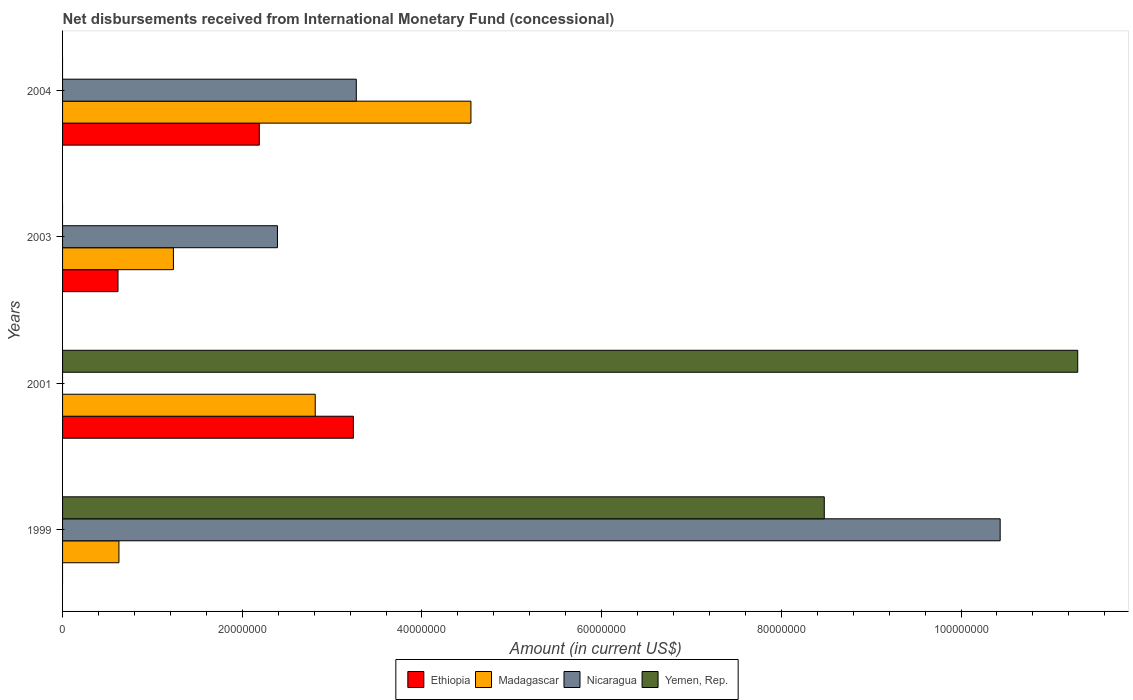How many bars are there on the 1st tick from the top?
Ensure brevity in your answer.  3. How many bars are there on the 3rd tick from the bottom?
Make the answer very short. 3. What is the amount of disbursements received from International Monetary Fund in Madagascar in 1999?
Keep it short and to the point. 6.27e+06. Across all years, what is the maximum amount of disbursements received from International Monetary Fund in Yemen, Rep.?
Keep it short and to the point. 1.13e+08. In which year was the amount of disbursements received from International Monetary Fund in Ethiopia maximum?
Provide a short and direct response. 2001. What is the total amount of disbursements received from International Monetary Fund in Yemen, Rep. in the graph?
Provide a short and direct response. 1.98e+08. What is the difference between the amount of disbursements received from International Monetary Fund in Ethiopia in 2001 and that in 2003?
Your response must be concise. 2.62e+07. What is the difference between the amount of disbursements received from International Monetary Fund in Nicaragua in 2001 and the amount of disbursements received from International Monetary Fund in Madagascar in 1999?
Provide a short and direct response. -6.27e+06. What is the average amount of disbursements received from International Monetary Fund in Yemen, Rep. per year?
Provide a short and direct response. 4.94e+07. In the year 2004, what is the difference between the amount of disbursements received from International Monetary Fund in Madagascar and amount of disbursements received from International Monetary Fund in Nicaragua?
Your answer should be compact. 1.28e+07. What is the ratio of the amount of disbursements received from International Monetary Fund in Madagascar in 1999 to that in 2003?
Your answer should be compact. 0.51. Is the amount of disbursements received from International Monetary Fund in Madagascar in 1999 less than that in 2004?
Your answer should be compact. Yes. What is the difference between the highest and the second highest amount of disbursements received from International Monetary Fund in Nicaragua?
Offer a very short reply. 7.17e+07. What is the difference between the highest and the lowest amount of disbursements received from International Monetary Fund in Madagascar?
Your answer should be very brief. 3.92e+07. Is the sum of the amount of disbursements received from International Monetary Fund in Madagascar in 2001 and 2003 greater than the maximum amount of disbursements received from International Monetary Fund in Yemen, Rep. across all years?
Your answer should be compact. No. Is it the case that in every year, the sum of the amount of disbursements received from International Monetary Fund in Nicaragua and amount of disbursements received from International Monetary Fund in Ethiopia is greater than the sum of amount of disbursements received from International Monetary Fund in Madagascar and amount of disbursements received from International Monetary Fund in Yemen, Rep.?
Offer a very short reply. No. Is it the case that in every year, the sum of the amount of disbursements received from International Monetary Fund in Madagascar and amount of disbursements received from International Monetary Fund in Ethiopia is greater than the amount of disbursements received from International Monetary Fund in Yemen, Rep.?
Your answer should be very brief. No. Are all the bars in the graph horizontal?
Provide a succinct answer. Yes. Are the values on the major ticks of X-axis written in scientific E-notation?
Ensure brevity in your answer.  No. Where does the legend appear in the graph?
Your response must be concise. Bottom center. What is the title of the graph?
Offer a terse response. Net disbursements received from International Monetary Fund (concessional). What is the Amount (in current US$) in Ethiopia in 1999?
Your response must be concise. 0. What is the Amount (in current US$) of Madagascar in 1999?
Your answer should be very brief. 6.27e+06. What is the Amount (in current US$) in Nicaragua in 1999?
Give a very brief answer. 1.04e+08. What is the Amount (in current US$) in Yemen, Rep. in 1999?
Your answer should be compact. 8.48e+07. What is the Amount (in current US$) of Ethiopia in 2001?
Keep it short and to the point. 3.24e+07. What is the Amount (in current US$) in Madagascar in 2001?
Make the answer very short. 2.81e+07. What is the Amount (in current US$) in Yemen, Rep. in 2001?
Your response must be concise. 1.13e+08. What is the Amount (in current US$) of Ethiopia in 2003?
Your answer should be very brief. 6.17e+06. What is the Amount (in current US$) of Madagascar in 2003?
Offer a terse response. 1.23e+07. What is the Amount (in current US$) in Nicaragua in 2003?
Provide a succinct answer. 2.39e+07. What is the Amount (in current US$) of Ethiopia in 2004?
Make the answer very short. 2.19e+07. What is the Amount (in current US$) in Madagascar in 2004?
Your answer should be very brief. 4.55e+07. What is the Amount (in current US$) in Nicaragua in 2004?
Your response must be concise. 3.27e+07. What is the Amount (in current US$) in Yemen, Rep. in 2004?
Offer a very short reply. 0. Across all years, what is the maximum Amount (in current US$) in Ethiopia?
Your answer should be very brief. 3.24e+07. Across all years, what is the maximum Amount (in current US$) in Madagascar?
Make the answer very short. 4.55e+07. Across all years, what is the maximum Amount (in current US$) of Nicaragua?
Your response must be concise. 1.04e+08. Across all years, what is the maximum Amount (in current US$) in Yemen, Rep.?
Offer a very short reply. 1.13e+08. Across all years, what is the minimum Amount (in current US$) in Ethiopia?
Provide a short and direct response. 0. Across all years, what is the minimum Amount (in current US$) in Madagascar?
Offer a very short reply. 6.27e+06. Across all years, what is the minimum Amount (in current US$) of Nicaragua?
Your answer should be compact. 0. Across all years, what is the minimum Amount (in current US$) of Yemen, Rep.?
Provide a succinct answer. 0. What is the total Amount (in current US$) of Ethiopia in the graph?
Offer a very short reply. 6.04e+07. What is the total Amount (in current US$) of Madagascar in the graph?
Your answer should be very brief. 9.22e+07. What is the total Amount (in current US$) in Nicaragua in the graph?
Give a very brief answer. 1.61e+08. What is the total Amount (in current US$) in Yemen, Rep. in the graph?
Offer a very short reply. 1.98e+08. What is the difference between the Amount (in current US$) in Madagascar in 1999 and that in 2001?
Your answer should be very brief. -2.18e+07. What is the difference between the Amount (in current US$) in Yemen, Rep. in 1999 and that in 2001?
Your answer should be compact. -2.82e+07. What is the difference between the Amount (in current US$) of Madagascar in 1999 and that in 2003?
Keep it short and to the point. -6.06e+06. What is the difference between the Amount (in current US$) of Nicaragua in 1999 and that in 2003?
Offer a terse response. 8.04e+07. What is the difference between the Amount (in current US$) of Madagascar in 1999 and that in 2004?
Offer a terse response. -3.92e+07. What is the difference between the Amount (in current US$) in Nicaragua in 1999 and that in 2004?
Keep it short and to the point. 7.17e+07. What is the difference between the Amount (in current US$) of Ethiopia in 2001 and that in 2003?
Make the answer very short. 2.62e+07. What is the difference between the Amount (in current US$) of Madagascar in 2001 and that in 2003?
Keep it short and to the point. 1.58e+07. What is the difference between the Amount (in current US$) of Ethiopia in 2001 and that in 2004?
Make the answer very short. 1.05e+07. What is the difference between the Amount (in current US$) in Madagascar in 2001 and that in 2004?
Your response must be concise. -1.73e+07. What is the difference between the Amount (in current US$) of Ethiopia in 2003 and that in 2004?
Ensure brevity in your answer.  -1.57e+07. What is the difference between the Amount (in current US$) of Madagascar in 2003 and that in 2004?
Ensure brevity in your answer.  -3.31e+07. What is the difference between the Amount (in current US$) of Nicaragua in 2003 and that in 2004?
Offer a very short reply. -8.78e+06. What is the difference between the Amount (in current US$) of Madagascar in 1999 and the Amount (in current US$) of Yemen, Rep. in 2001?
Ensure brevity in your answer.  -1.07e+08. What is the difference between the Amount (in current US$) of Nicaragua in 1999 and the Amount (in current US$) of Yemen, Rep. in 2001?
Ensure brevity in your answer.  -8.63e+06. What is the difference between the Amount (in current US$) of Madagascar in 1999 and the Amount (in current US$) of Nicaragua in 2003?
Your answer should be very brief. -1.76e+07. What is the difference between the Amount (in current US$) of Madagascar in 1999 and the Amount (in current US$) of Nicaragua in 2004?
Your response must be concise. -2.64e+07. What is the difference between the Amount (in current US$) in Ethiopia in 2001 and the Amount (in current US$) in Madagascar in 2003?
Ensure brevity in your answer.  2.00e+07. What is the difference between the Amount (in current US$) in Ethiopia in 2001 and the Amount (in current US$) in Nicaragua in 2003?
Keep it short and to the point. 8.45e+06. What is the difference between the Amount (in current US$) in Madagascar in 2001 and the Amount (in current US$) in Nicaragua in 2003?
Provide a succinct answer. 4.21e+06. What is the difference between the Amount (in current US$) of Ethiopia in 2001 and the Amount (in current US$) of Madagascar in 2004?
Offer a terse response. -1.31e+07. What is the difference between the Amount (in current US$) in Ethiopia in 2001 and the Amount (in current US$) in Nicaragua in 2004?
Your response must be concise. -3.25e+05. What is the difference between the Amount (in current US$) in Madagascar in 2001 and the Amount (in current US$) in Nicaragua in 2004?
Give a very brief answer. -4.57e+06. What is the difference between the Amount (in current US$) in Ethiopia in 2003 and the Amount (in current US$) in Madagascar in 2004?
Provide a short and direct response. -3.93e+07. What is the difference between the Amount (in current US$) in Ethiopia in 2003 and the Amount (in current US$) in Nicaragua in 2004?
Give a very brief answer. -2.65e+07. What is the difference between the Amount (in current US$) of Madagascar in 2003 and the Amount (in current US$) of Nicaragua in 2004?
Your response must be concise. -2.04e+07. What is the average Amount (in current US$) in Ethiopia per year?
Give a very brief answer. 1.51e+07. What is the average Amount (in current US$) of Madagascar per year?
Provide a short and direct response. 2.30e+07. What is the average Amount (in current US$) of Nicaragua per year?
Keep it short and to the point. 4.02e+07. What is the average Amount (in current US$) in Yemen, Rep. per year?
Provide a succinct answer. 4.94e+07. In the year 1999, what is the difference between the Amount (in current US$) in Madagascar and Amount (in current US$) in Nicaragua?
Give a very brief answer. -9.81e+07. In the year 1999, what is the difference between the Amount (in current US$) of Madagascar and Amount (in current US$) of Yemen, Rep.?
Your answer should be very brief. -7.85e+07. In the year 1999, what is the difference between the Amount (in current US$) of Nicaragua and Amount (in current US$) of Yemen, Rep.?
Provide a short and direct response. 1.96e+07. In the year 2001, what is the difference between the Amount (in current US$) in Ethiopia and Amount (in current US$) in Madagascar?
Offer a very short reply. 4.24e+06. In the year 2001, what is the difference between the Amount (in current US$) in Ethiopia and Amount (in current US$) in Yemen, Rep.?
Provide a succinct answer. -8.06e+07. In the year 2001, what is the difference between the Amount (in current US$) in Madagascar and Amount (in current US$) in Yemen, Rep.?
Provide a succinct answer. -8.49e+07. In the year 2003, what is the difference between the Amount (in current US$) of Ethiopia and Amount (in current US$) of Madagascar?
Your answer should be compact. -6.17e+06. In the year 2003, what is the difference between the Amount (in current US$) of Ethiopia and Amount (in current US$) of Nicaragua?
Give a very brief answer. -1.77e+07. In the year 2003, what is the difference between the Amount (in current US$) in Madagascar and Amount (in current US$) in Nicaragua?
Offer a very short reply. -1.16e+07. In the year 2004, what is the difference between the Amount (in current US$) in Ethiopia and Amount (in current US$) in Madagascar?
Give a very brief answer. -2.36e+07. In the year 2004, what is the difference between the Amount (in current US$) of Ethiopia and Amount (in current US$) of Nicaragua?
Keep it short and to the point. -1.08e+07. In the year 2004, what is the difference between the Amount (in current US$) of Madagascar and Amount (in current US$) of Nicaragua?
Your response must be concise. 1.28e+07. What is the ratio of the Amount (in current US$) in Madagascar in 1999 to that in 2001?
Offer a terse response. 0.22. What is the ratio of the Amount (in current US$) of Yemen, Rep. in 1999 to that in 2001?
Offer a very short reply. 0.75. What is the ratio of the Amount (in current US$) in Madagascar in 1999 to that in 2003?
Provide a succinct answer. 0.51. What is the ratio of the Amount (in current US$) in Nicaragua in 1999 to that in 2003?
Offer a terse response. 4.36. What is the ratio of the Amount (in current US$) in Madagascar in 1999 to that in 2004?
Provide a short and direct response. 0.14. What is the ratio of the Amount (in current US$) of Nicaragua in 1999 to that in 2004?
Your response must be concise. 3.19. What is the ratio of the Amount (in current US$) of Ethiopia in 2001 to that in 2003?
Offer a very short reply. 5.25. What is the ratio of the Amount (in current US$) in Madagascar in 2001 to that in 2003?
Keep it short and to the point. 2.28. What is the ratio of the Amount (in current US$) in Ethiopia in 2001 to that in 2004?
Offer a very short reply. 1.48. What is the ratio of the Amount (in current US$) in Madagascar in 2001 to that in 2004?
Provide a short and direct response. 0.62. What is the ratio of the Amount (in current US$) of Ethiopia in 2003 to that in 2004?
Provide a short and direct response. 0.28. What is the ratio of the Amount (in current US$) of Madagascar in 2003 to that in 2004?
Offer a terse response. 0.27. What is the ratio of the Amount (in current US$) of Nicaragua in 2003 to that in 2004?
Make the answer very short. 0.73. What is the difference between the highest and the second highest Amount (in current US$) in Ethiopia?
Offer a terse response. 1.05e+07. What is the difference between the highest and the second highest Amount (in current US$) of Madagascar?
Provide a succinct answer. 1.73e+07. What is the difference between the highest and the second highest Amount (in current US$) in Nicaragua?
Ensure brevity in your answer.  7.17e+07. What is the difference between the highest and the lowest Amount (in current US$) of Ethiopia?
Provide a short and direct response. 3.24e+07. What is the difference between the highest and the lowest Amount (in current US$) of Madagascar?
Ensure brevity in your answer.  3.92e+07. What is the difference between the highest and the lowest Amount (in current US$) of Nicaragua?
Keep it short and to the point. 1.04e+08. What is the difference between the highest and the lowest Amount (in current US$) in Yemen, Rep.?
Provide a succinct answer. 1.13e+08. 